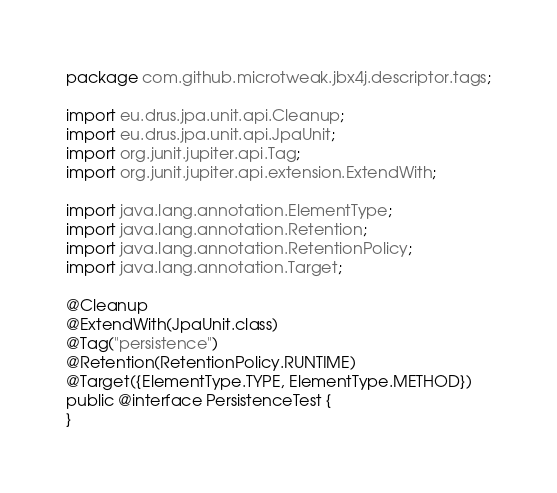<code> <loc_0><loc_0><loc_500><loc_500><_Java_>package com.github.microtweak.jbx4j.descriptor.tags;

import eu.drus.jpa.unit.api.Cleanup;
import eu.drus.jpa.unit.api.JpaUnit;
import org.junit.jupiter.api.Tag;
import org.junit.jupiter.api.extension.ExtendWith;

import java.lang.annotation.ElementType;
import java.lang.annotation.Retention;
import java.lang.annotation.RetentionPolicy;
import java.lang.annotation.Target;

@Cleanup
@ExtendWith(JpaUnit.class)
@Tag("persistence")
@Retention(RetentionPolicy.RUNTIME)
@Target({ElementType.TYPE, ElementType.METHOD})
public @interface PersistenceTest {
}
</code> 